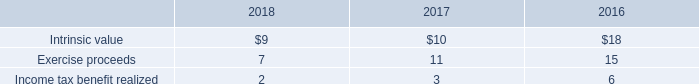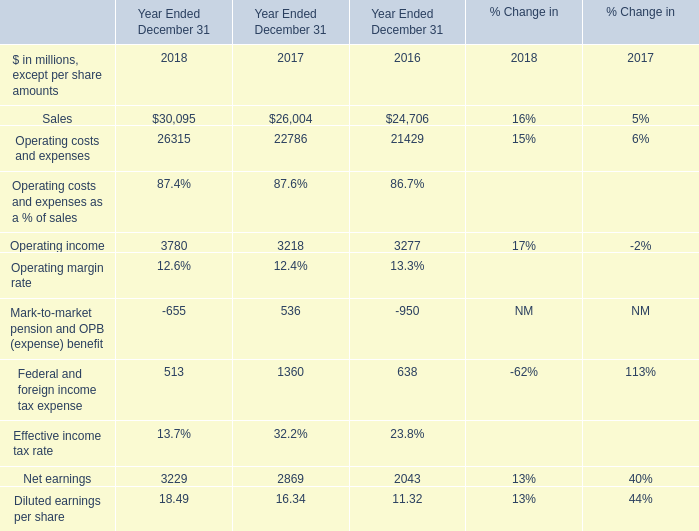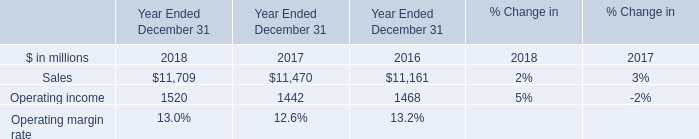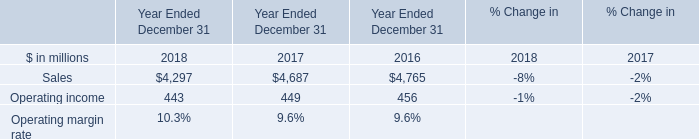What is the average amount of Sales of Year Ended December 31 2018, and Net earnings of Year Ended December 31 2018 ? 
Computations: ((4297.0 + 3229.0) / 2)
Answer: 3763.0. 